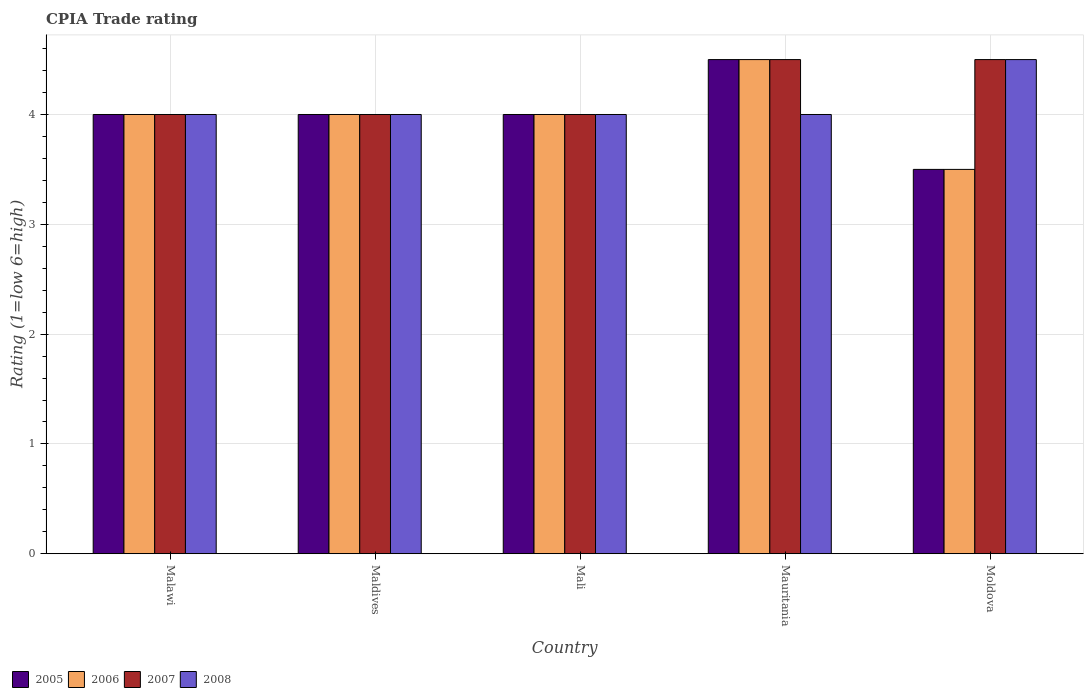How many different coloured bars are there?
Keep it short and to the point. 4. How many groups of bars are there?
Ensure brevity in your answer.  5. Are the number of bars on each tick of the X-axis equal?
Offer a terse response. Yes. How many bars are there on the 3rd tick from the left?
Provide a succinct answer. 4. How many bars are there on the 5th tick from the right?
Keep it short and to the point. 4. What is the label of the 5th group of bars from the left?
Give a very brief answer. Moldova. Across all countries, what is the maximum CPIA rating in 2008?
Give a very brief answer. 4.5. In which country was the CPIA rating in 2007 maximum?
Your answer should be very brief. Mauritania. In which country was the CPIA rating in 2007 minimum?
Provide a short and direct response. Malawi. What is the total CPIA rating in 2007 in the graph?
Your answer should be very brief. 21. What is the difference between the CPIA rating in 2005 in Malawi and the CPIA rating in 2008 in Mauritania?
Offer a terse response. 0. What is the average CPIA rating in 2006 per country?
Your response must be concise. 4. In how many countries, is the CPIA rating in 2005 greater than 0.2?
Provide a short and direct response. 5. What is the ratio of the CPIA rating in 2008 in Maldives to that in Moldova?
Make the answer very short. 0.89. Is the difference between the CPIA rating in 2005 in Maldives and Mauritania greater than the difference between the CPIA rating in 2007 in Maldives and Mauritania?
Offer a terse response. No. What is the difference between the highest and the second highest CPIA rating in 2008?
Give a very brief answer. 0.5. What is the difference between the highest and the lowest CPIA rating in 2008?
Your response must be concise. 0.5. In how many countries, is the CPIA rating in 2005 greater than the average CPIA rating in 2005 taken over all countries?
Give a very brief answer. 1. Is the sum of the CPIA rating in 2005 in Malawi and Mali greater than the maximum CPIA rating in 2006 across all countries?
Ensure brevity in your answer.  Yes. Is it the case that in every country, the sum of the CPIA rating in 2006 and CPIA rating in 2007 is greater than the sum of CPIA rating in 2008 and CPIA rating in 2005?
Your answer should be compact. No. What does the 1st bar from the left in Moldova represents?
Give a very brief answer. 2005. What does the 3rd bar from the right in Mauritania represents?
Your answer should be compact. 2006. Is it the case that in every country, the sum of the CPIA rating in 2008 and CPIA rating in 2007 is greater than the CPIA rating in 2005?
Offer a very short reply. Yes. How many bars are there?
Offer a terse response. 20. What is the difference between two consecutive major ticks on the Y-axis?
Keep it short and to the point. 1. Are the values on the major ticks of Y-axis written in scientific E-notation?
Offer a very short reply. No. Does the graph contain any zero values?
Your answer should be compact. No. Does the graph contain grids?
Provide a short and direct response. Yes. Where does the legend appear in the graph?
Your answer should be very brief. Bottom left. How are the legend labels stacked?
Offer a very short reply. Horizontal. What is the title of the graph?
Offer a terse response. CPIA Trade rating. Does "2014" appear as one of the legend labels in the graph?
Give a very brief answer. No. What is the label or title of the X-axis?
Your response must be concise. Country. What is the label or title of the Y-axis?
Your response must be concise. Rating (1=low 6=high). What is the Rating (1=low 6=high) of 2005 in Malawi?
Offer a very short reply. 4. What is the Rating (1=low 6=high) in 2006 in Malawi?
Provide a short and direct response. 4. What is the Rating (1=low 6=high) in 2008 in Malawi?
Ensure brevity in your answer.  4. What is the Rating (1=low 6=high) in 2006 in Mali?
Provide a short and direct response. 4. What is the Rating (1=low 6=high) of 2007 in Mali?
Provide a short and direct response. 4. What is the Rating (1=low 6=high) in 2008 in Mali?
Provide a short and direct response. 4. What is the Rating (1=low 6=high) in 2008 in Mauritania?
Offer a terse response. 4. What is the Rating (1=low 6=high) in 2006 in Moldova?
Make the answer very short. 3.5. What is the Rating (1=low 6=high) of 2007 in Moldova?
Provide a short and direct response. 4.5. Across all countries, what is the maximum Rating (1=low 6=high) in 2005?
Your answer should be compact. 4.5. Across all countries, what is the maximum Rating (1=low 6=high) of 2007?
Give a very brief answer. 4.5. Across all countries, what is the maximum Rating (1=low 6=high) of 2008?
Your response must be concise. 4.5. Across all countries, what is the minimum Rating (1=low 6=high) in 2005?
Ensure brevity in your answer.  3.5. Across all countries, what is the minimum Rating (1=low 6=high) in 2006?
Your answer should be very brief. 3.5. What is the difference between the Rating (1=low 6=high) of 2005 in Malawi and that in Maldives?
Your response must be concise. 0. What is the difference between the Rating (1=low 6=high) of 2006 in Malawi and that in Maldives?
Provide a succinct answer. 0. What is the difference between the Rating (1=low 6=high) in 2006 in Malawi and that in Mali?
Make the answer very short. 0. What is the difference between the Rating (1=low 6=high) of 2005 in Malawi and that in Mauritania?
Your answer should be compact. -0.5. What is the difference between the Rating (1=low 6=high) of 2006 in Malawi and that in Mauritania?
Make the answer very short. -0.5. What is the difference between the Rating (1=low 6=high) of 2008 in Malawi and that in Moldova?
Give a very brief answer. -0.5. What is the difference between the Rating (1=low 6=high) of 2005 in Maldives and that in Mauritania?
Make the answer very short. -0.5. What is the difference between the Rating (1=low 6=high) in 2006 in Maldives and that in Mauritania?
Ensure brevity in your answer.  -0.5. What is the difference between the Rating (1=low 6=high) in 2007 in Maldives and that in Mauritania?
Offer a terse response. -0.5. What is the difference between the Rating (1=low 6=high) of 2008 in Maldives and that in Mauritania?
Provide a succinct answer. 0. What is the difference between the Rating (1=low 6=high) of 2005 in Maldives and that in Moldova?
Your answer should be very brief. 0.5. What is the difference between the Rating (1=low 6=high) of 2007 in Maldives and that in Moldova?
Your response must be concise. -0.5. What is the difference between the Rating (1=low 6=high) of 2006 in Mali and that in Mauritania?
Your answer should be very brief. -0.5. What is the difference between the Rating (1=low 6=high) of 2008 in Mali and that in Moldova?
Offer a very short reply. -0.5. What is the difference between the Rating (1=low 6=high) of 2006 in Mauritania and that in Moldova?
Make the answer very short. 1. What is the difference between the Rating (1=low 6=high) in 2008 in Mauritania and that in Moldova?
Your answer should be very brief. -0.5. What is the difference between the Rating (1=low 6=high) of 2005 in Malawi and the Rating (1=low 6=high) of 2006 in Maldives?
Provide a succinct answer. 0. What is the difference between the Rating (1=low 6=high) of 2006 in Malawi and the Rating (1=low 6=high) of 2008 in Maldives?
Your answer should be compact. 0. What is the difference between the Rating (1=low 6=high) of 2005 in Malawi and the Rating (1=low 6=high) of 2007 in Mali?
Your response must be concise. 0. What is the difference between the Rating (1=low 6=high) of 2006 in Malawi and the Rating (1=low 6=high) of 2007 in Mali?
Make the answer very short. 0. What is the difference between the Rating (1=low 6=high) in 2005 in Malawi and the Rating (1=low 6=high) in 2007 in Mauritania?
Give a very brief answer. -0.5. What is the difference between the Rating (1=low 6=high) of 2006 in Malawi and the Rating (1=low 6=high) of 2008 in Mauritania?
Your answer should be very brief. 0. What is the difference between the Rating (1=low 6=high) in 2007 in Malawi and the Rating (1=low 6=high) in 2008 in Mauritania?
Provide a short and direct response. 0. What is the difference between the Rating (1=low 6=high) in 2007 in Malawi and the Rating (1=low 6=high) in 2008 in Moldova?
Your answer should be compact. -0.5. What is the difference between the Rating (1=low 6=high) in 2005 in Maldives and the Rating (1=low 6=high) in 2008 in Mali?
Your answer should be compact. 0. What is the difference between the Rating (1=low 6=high) in 2006 in Maldives and the Rating (1=low 6=high) in 2007 in Mali?
Make the answer very short. 0. What is the difference between the Rating (1=low 6=high) of 2007 in Maldives and the Rating (1=low 6=high) of 2008 in Mali?
Keep it short and to the point. 0. What is the difference between the Rating (1=low 6=high) of 2006 in Maldives and the Rating (1=low 6=high) of 2007 in Mauritania?
Offer a terse response. -0.5. What is the difference between the Rating (1=low 6=high) of 2006 in Maldives and the Rating (1=low 6=high) of 2008 in Mauritania?
Your answer should be very brief. 0. What is the difference between the Rating (1=low 6=high) of 2006 in Maldives and the Rating (1=low 6=high) of 2007 in Moldova?
Ensure brevity in your answer.  -0.5. What is the difference between the Rating (1=low 6=high) of 2005 in Mali and the Rating (1=low 6=high) of 2007 in Mauritania?
Make the answer very short. -0.5. What is the difference between the Rating (1=low 6=high) of 2005 in Mali and the Rating (1=low 6=high) of 2008 in Mauritania?
Offer a very short reply. 0. What is the difference between the Rating (1=low 6=high) in 2006 in Mali and the Rating (1=low 6=high) in 2008 in Mauritania?
Provide a short and direct response. 0. What is the difference between the Rating (1=low 6=high) in 2005 in Mali and the Rating (1=low 6=high) in 2007 in Moldova?
Provide a short and direct response. -0.5. What is the difference between the Rating (1=low 6=high) of 2006 in Mali and the Rating (1=low 6=high) of 2007 in Moldova?
Ensure brevity in your answer.  -0.5. What is the difference between the Rating (1=low 6=high) of 2007 in Mali and the Rating (1=low 6=high) of 2008 in Moldova?
Ensure brevity in your answer.  -0.5. What is the difference between the Rating (1=low 6=high) of 2005 in Mauritania and the Rating (1=low 6=high) of 2007 in Moldova?
Keep it short and to the point. 0. What is the difference between the Rating (1=low 6=high) of 2005 in Mauritania and the Rating (1=low 6=high) of 2008 in Moldova?
Provide a short and direct response. 0. What is the average Rating (1=low 6=high) in 2006 per country?
Give a very brief answer. 4. What is the average Rating (1=low 6=high) of 2007 per country?
Keep it short and to the point. 4.2. What is the difference between the Rating (1=low 6=high) of 2005 and Rating (1=low 6=high) of 2006 in Malawi?
Offer a terse response. 0. What is the difference between the Rating (1=low 6=high) in 2005 and Rating (1=low 6=high) in 2007 in Malawi?
Your response must be concise. 0. What is the difference between the Rating (1=low 6=high) in 2005 and Rating (1=low 6=high) in 2008 in Malawi?
Your answer should be compact. 0. What is the difference between the Rating (1=low 6=high) in 2006 and Rating (1=low 6=high) in 2007 in Malawi?
Provide a short and direct response. 0. What is the difference between the Rating (1=low 6=high) of 2007 and Rating (1=low 6=high) of 2008 in Malawi?
Provide a short and direct response. 0. What is the difference between the Rating (1=low 6=high) of 2006 and Rating (1=low 6=high) of 2007 in Maldives?
Provide a short and direct response. 0. What is the difference between the Rating (1=low 6=high) of 2006 and Rating (1=low 6=high) of 2008 in Maldives?
Provide a succinct answer. 0. What is the difference between the Rating (1=low 6=high) in 2005 and Rating (1=low 6=high) in 2006 in Mali?
Ensure brevity in your answer.  0. What is the difference between the Rating (1=low 6=high) of 2005 and Rating (1=low 6=high) of 2007 in Mali?
Offer a very short reply. 0. What is the difference between the Rating (1=low 6=high) in 2005 and Rating (1=low 6=high) in 2008 in Mali?
Your answer should be compact. 0. What is the difference between the Rating (1=low 6=high) in 2006 and Rating (1=low 6=high) in 2007 in Mali?
Provide a succinct answer. 0. What is the difference between the Rating (1=low 6=high) of 2006 and Rating (1=low 6=high) of 2008 in Mali?
Ensure brevity in your answer.  0. What is the difference between the Rating (1=low 6=high) in 2005 and Rating (1=low 6=high) in 2006 in Mauritania?
Your answer should be compact. 0. What is the difference between the Rating (1=low 6=high) of 2005 and Rating (1=low 6=high) of 2008 in Mauritania?
Offer a very short reply. 0.5. What is the difference between the Rating (1=low 6=high) of 2007 and Rating (1=low 6=high) of 2008 in Mauritania?
Your answer should be very brief. 0.5. What is the difference between the Rating (1=low 6=high) of 2005 and Rating (1=low 6=high) of 2007 in Moldova?
Provide a short and direct response. -1. What is the difference between the Rating (1=low 6=high) in 2005 and Rating (1=low 6=high) in 2008 in Moldova?
Your answer should be compact. -1. What is the difference between the Rating (1=low 6=high) in 2006 and Rating (1=low 6=high) in 2007 in Moldova?
Your response must be concise. -1. What is the difference between the Rating (1=low 6=high) in 2006 and Rating (1=low 6=high) in 2008 in Moldova?
Offer a terse response. -1. What is the difference between the Rating (1=low 6=high) in 2007 and Rating (1=low 6=high) in 2008 in Moldova?
Your answer should be compact. 0. What is the ratio of the Rating (1=low 6=high) in 2006 in Malawi to that in Maldives?
Offer a very short reply. 1. What is the ratio of the Rating (1=low 6=high) in 2008 in Malawi to that in Maldives?
Offer a very short reply. 1. What is the ratio of the Rating (1=low 6=high) of 2007 in Malawi to that in Mali?
Your answer should be very brief. 1. What is the ratio of the Rating (1=low 6=high) in 2005 in Malawi to that in Mauritania?
Offer a very short reply. 0.89. What is the ratio of the Rating (1=low 6=high) in 2006 in Malawi to that in Mauritania?
Provide a succinct answer. 0.89. What is the ratio of the Rating (1=low 6=high) in 2007 in Malawi to that in Mauritania?
Provide a short and direct response. 0.89. What is the ratio of the Rating (1=low 6=high) in 2008 in Malawi to that in Mauritania?
Give a very brief answer. 1. What is the ratio of the Rating (1=low 6=high) of 2007 in Malawi to that in Moldova?
Your answer should be very brief. 0.89. What is the ratio of the Rating (1=low 6=high) in 2005 in Maldives to that in Mali?
Offer a very short reply. 1. What is the ratio of the Rating (1=low 6=high) of 2006 in Maldives to that in Mali?
Ensure brevity in your answer.  1. What is the ratio of the Rating (1=low 6=high) of 2007 in Maldives to that in Mali?
Offer a very short reply. 1. What is the ratio of the Rating (1=low 6=high) of 2005 in Maldives to that in Mauritania?
Provide a succinct answer. 0.89. What is the ratio of the Rating (1=low 6=high) in 2006 in Maldives to that in Mauritania?
Offer a terse response. 0.89. What is the ratio of the Rating (1=low 6=high) of 2008 in Maldives to that in Mauritania?
Provide a short and direct response. 1. What is the ratio of the Rating (1=low 6=high) in 2007 in Maldives to that in Moldova?
Your answer should be very brief. 0.89. What is the ratio of the Rating (1=low 6=high) of 2008 in Maldives to that in Moldova?
Your answer should be very brief. 0.89. What is the ratio of the Rating (1=low 6=high) in 2006 in Mali to that in Mauritania?
Provide a succinct answer. 0.89. What is the ratio of the Rating (1=low 6=high) in 2008 in Mali to that in Mauritania?
Ensure brevity in your answer.  1. What is the ratio of the Rating (1=low 6=high) of 2005 in Mali to that in Moldova?
Offer a very short reply. 1.14. What is the ratio of the Rating (1=low 6=high) of 2006 in Mali to that in Moldova?
Your answer should be very brief. 1.14. What is the ratio of the Rating (1=low 6=high) in 2008 in Mali to that in Moldova?
Give a very brief answer. 0.89. What is the ratio of the Rating (1=low 6=high) of 2008 in Mauritania to that in Moldova?
Provide a short and direct response. 0.89. What is the difference between the highest and the second highest Rating (1=low 6=high) of 2006?
Give a very brief answer. 0.5. What is the difference between the highest and the second highest Rating (1=low 6=high) of 2007?
Your answer should be compact. 0. What is the difference between the highest and the lowest Rating (1=low 6=high) in 2006?
Offer a terse response. 1. What is the difference between the highest and the lowest Rating (1=low 6=high) in 2007?
Your answer should be very brief. 0.5. What is the difference between the highest and the lowest Rating (1=low 6=high) in 2008?
Provide a succinct answer. 0.5. 